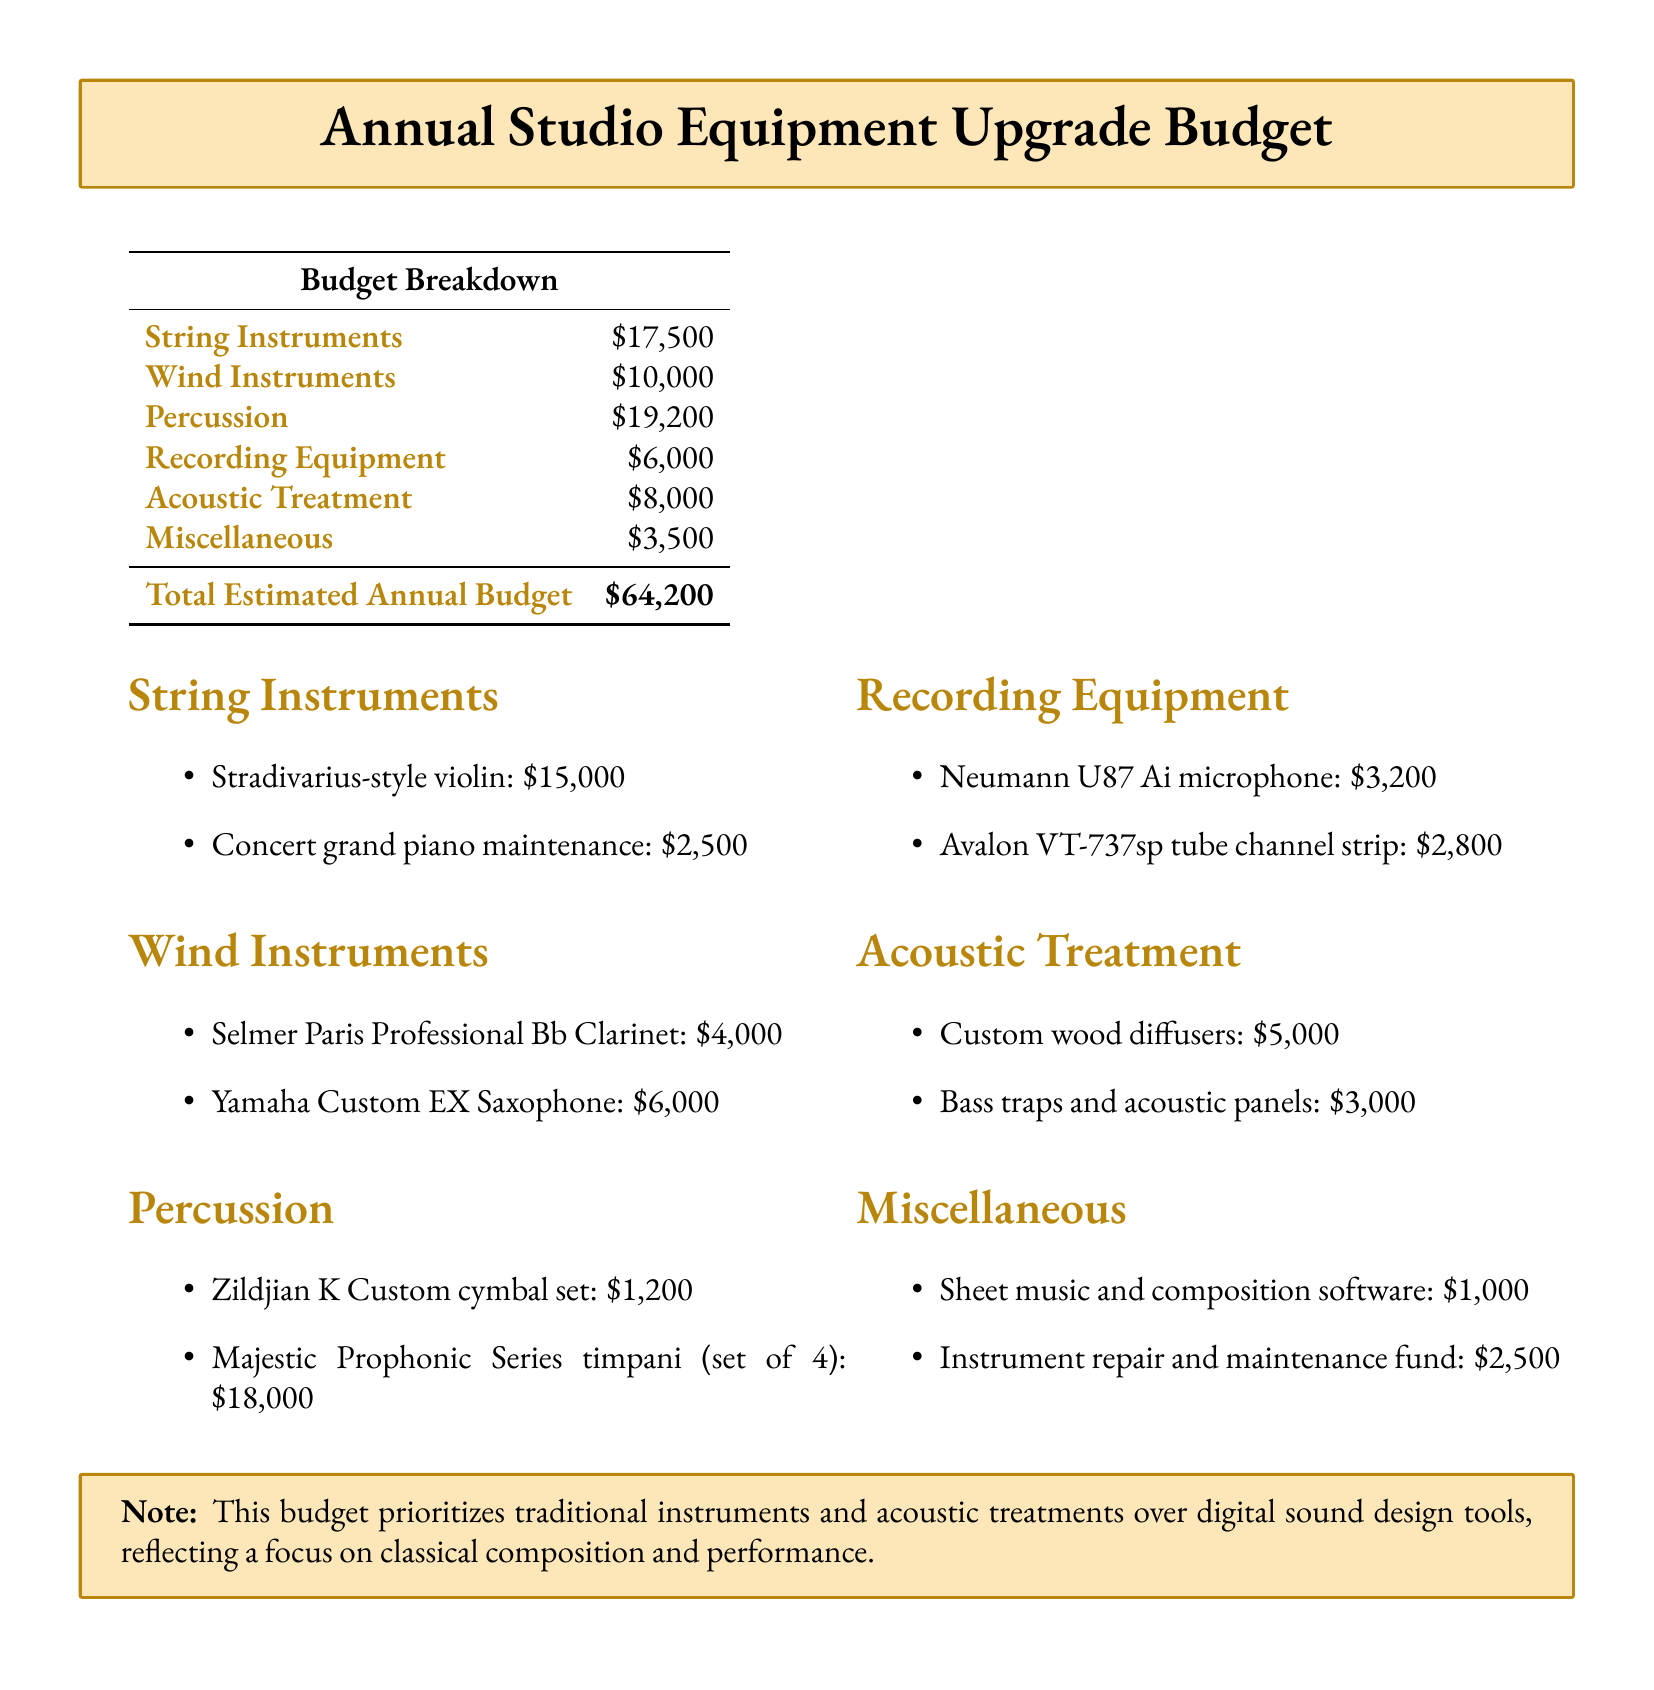What is the total estimated annual budget? The total estimated annual budget is listed at the bottom of the document as the sum of all categories.
Answer: $64,200 How much is allocated for string instruments? The budget specifically lists the amount allocated for string instruments under the "Budget Breakdown" section.
Answer: $17,500 What is the cost of a Selmer Paris Professional Bb Clarinet? The document provides a specific itemized cost for this instrument under the "Wind Instruments" section.
Answer: $4,000 Which percussion item has the highest cost? Reasoning from the list of percussion instruments, the highest cost item can be identified.
Answer: Majestic Prophonic Series timpani (set of 4) What is the total cost of acoustic treatment? The budget includes a specific amount for the acoustic treatment category, requiring only simple addition of its individual components if needed.
Answer: $8,000 What is the cost of the Neumann U87 Ai microphone? The microphone's cost is detailed among the recording equipment section of the budget.
Answer: $3,200 How much is set aside for miscellaneous expenses? The document explicitly states the budget for miscellaneous expenses in the "Budget Breakdown" section.
Answer: $3,500 What principal instruments are prioritized in this budget? The budget centers around traditional instruments rather than digital tools, which reflects on the overall focus of the document.
Answer: Traditional instruments What is the cost of the custom wood diffusers? The document lists specific expenses related to acoustic treatment, including this item.
Answer: $5,000 